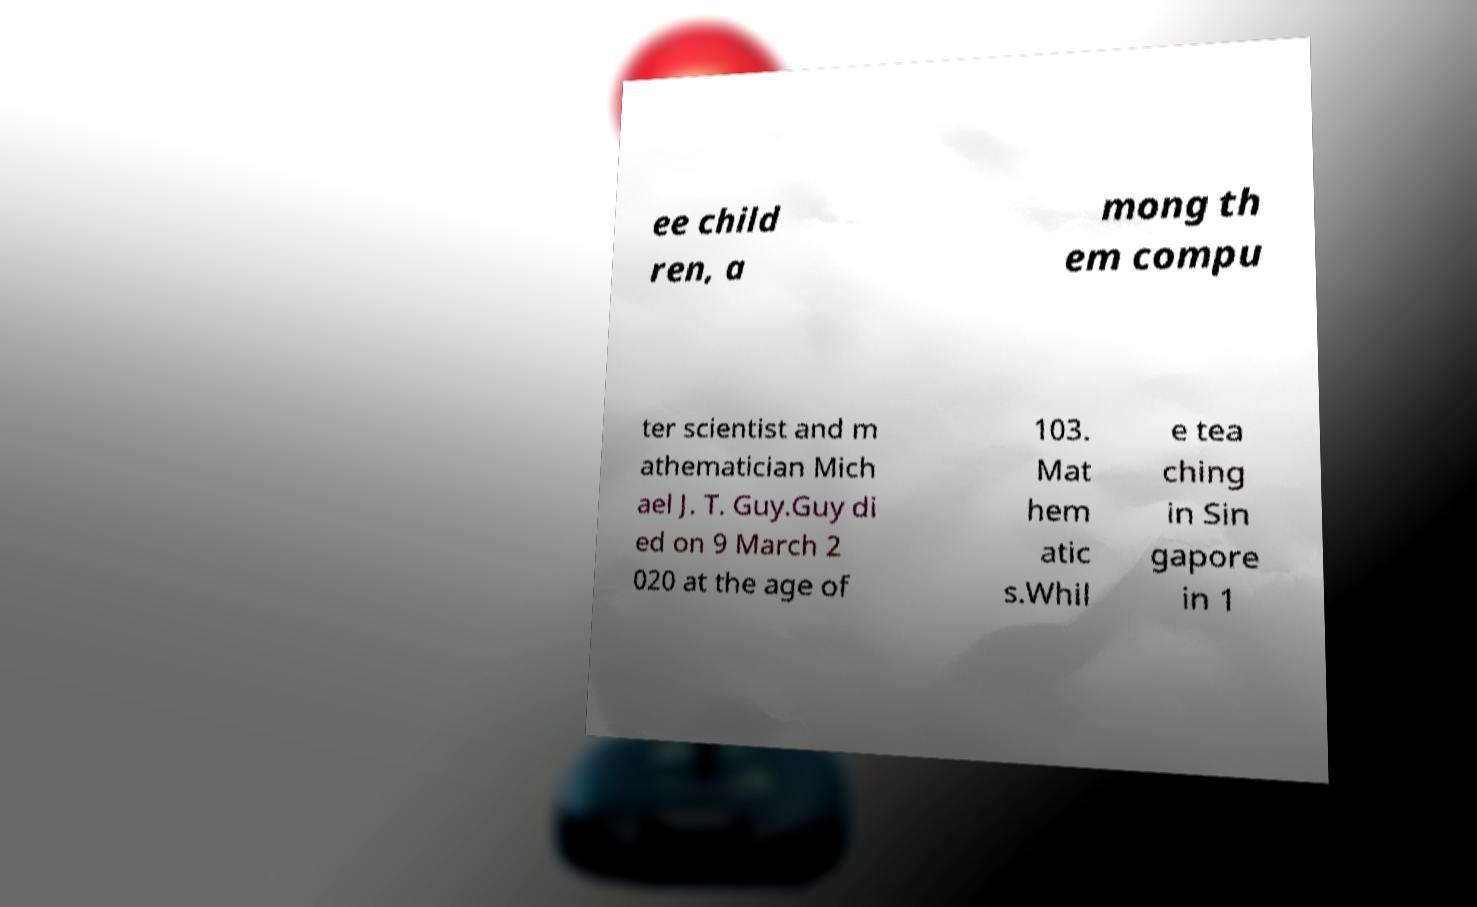Can you read and provide the text displayed in the image?This photo seems to have some interesting text. Can you extract and type it out for me? ee child ren, a mong th em compu ter scientist and m athematician Mich ael J. T. Guy.Guy di ed on 9 March 2 020 at the age of 103. Mat hem atic s.Whil e tea ching in Sin gapore in 1 